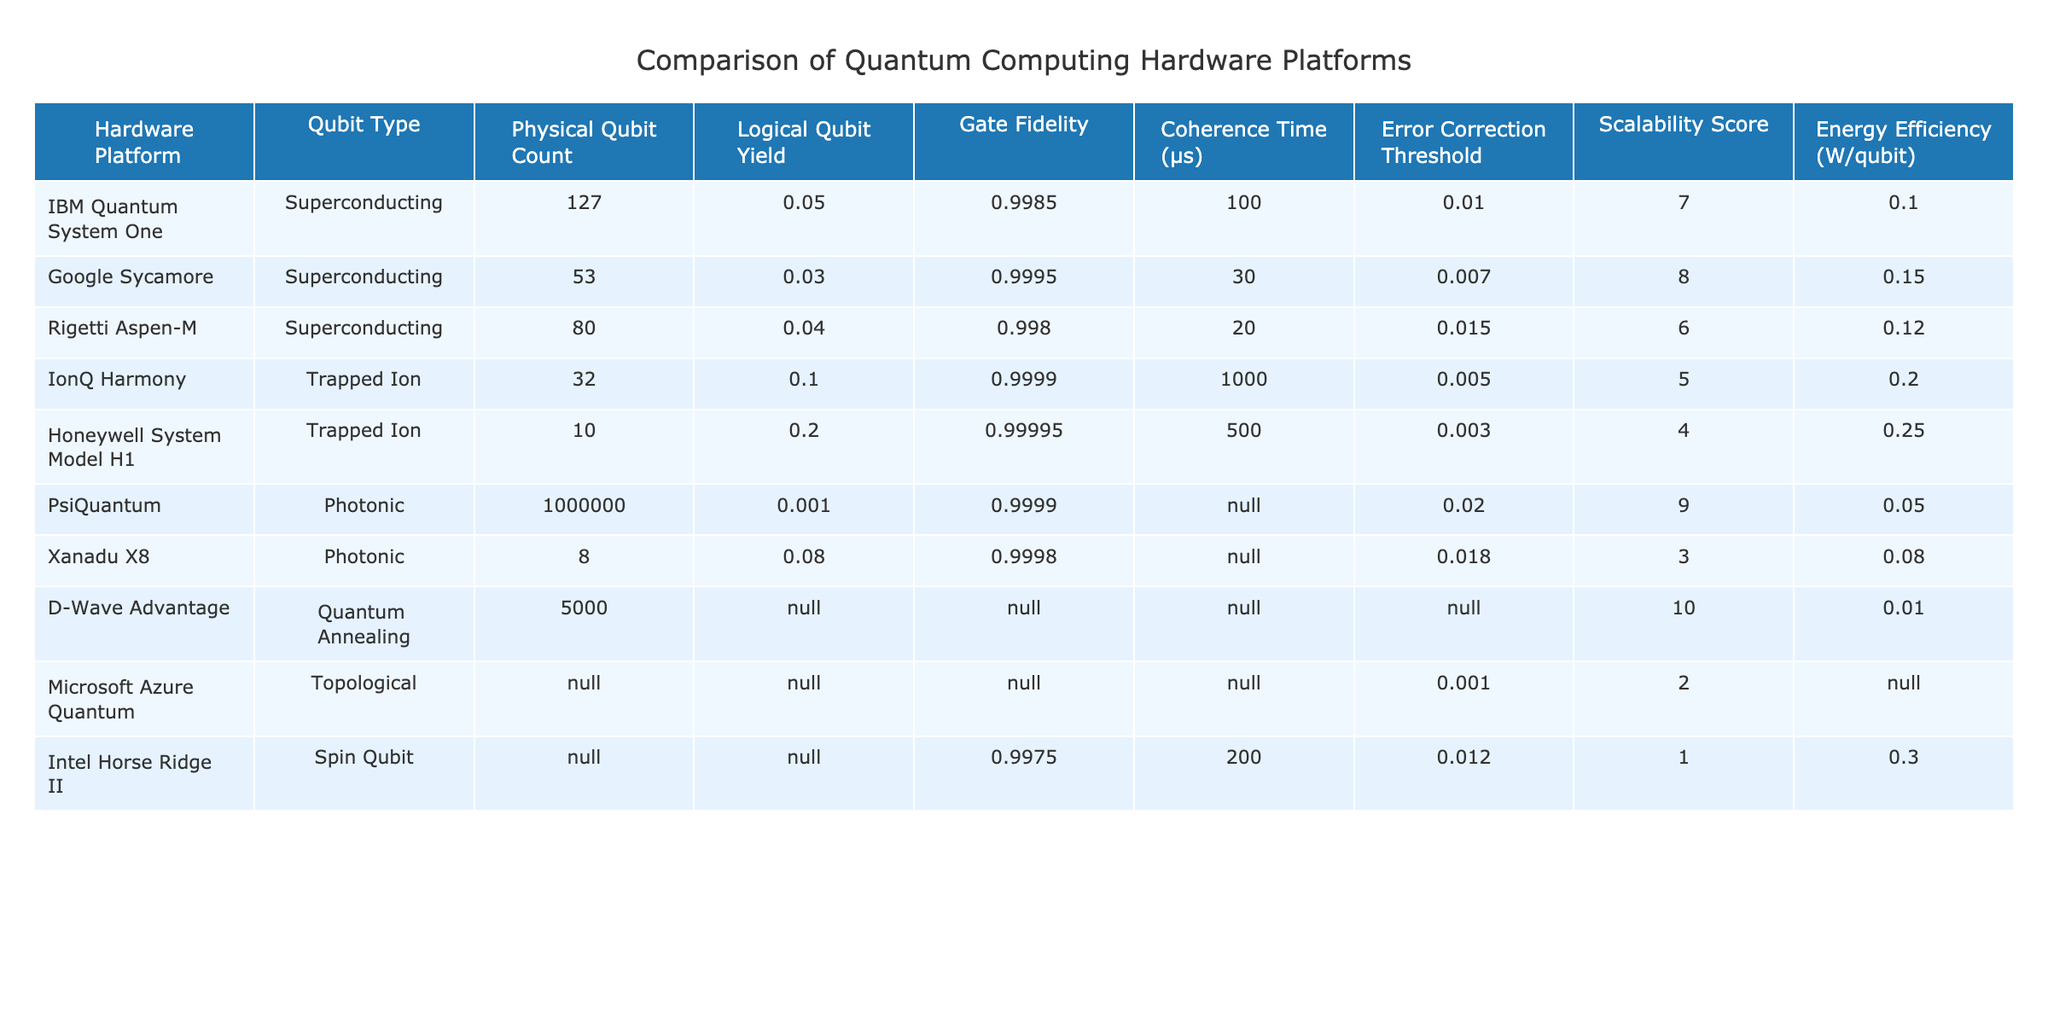What is the gate fidelity of the IonQ Harmony platform? The gate fidelity for IonQ Harmony can be found in the "Gate Fidelity" column, where it is listed as 0.9999.
Answer: 0.9999 Which hardware platform has the highest logical qubit yield? To determine the highest logical qubit yield, I compare the "Logical Qubit Yield" values across all platforms. The Honeywell System Model H1 has the highest yield of 0.2.
Answer: Honeywell System Model H1 What is the total number of physical qubits across all superconducting platforms? The total is calculated by summing the physical qubit counts of the superconducting platforms: 127 (IBM) + 53 (Google) + 80 (Rigetti) = 260.
Answer: 260 Is the error correction threshold of Google Sycamore higher than that of Honeywell System Model H1? I cross-reference the values in the "Error Correction Threshold" column: Google Sycamore has a threshold of 0.007 while Honeywell System Model H1 has 0.003. Since 0.007 is greater than 0.003, the answer is yes.
Answer: Yes What is the average energy efficiency of the photonic platforms? To find the average energy efficiency, I take the energy values for PsiQuantum (0.05) and Xanadu X8 (0.08), sum them (0.05 + 0.08 = 0.13), and divide by 2, giving an average of 0.065.
Answer: 0.065 Which platform has the best scalability score among the trapped ion platforms? The scalability scores for the trapped ion platforms are compared: IonQ Harmony has a score of 5, and Honeywell System Model H1 has a score of 4. Therefore, IonQ Harmony has the best score among them.
Answer: IonQ Harmony What is the difference in the coherence time between IonQ Harmony and Intel Horse Ridge II? The coherence time for IonQ Harmony is 1000 μs and for Intel Horse Ridge II it is listed as 200 μs. The difference is 1000 - 200 = 800 μs.
Answer: 800 μs Does the D-Wave Advantage have a listed value for logical qubits yield? I check the "Logical Qubit Yield" column for D-Wave Advantage, and it shows N/A, indicating that there is no value provided.
Answer: No What is the highest gate fidelity among the platforms listed? I examine the "Gate Fidelity" column for the highest value: IonQ Harmony at 0.9999 is the highest gate fidelity among all listed platforms.
Answer: 0.9999 